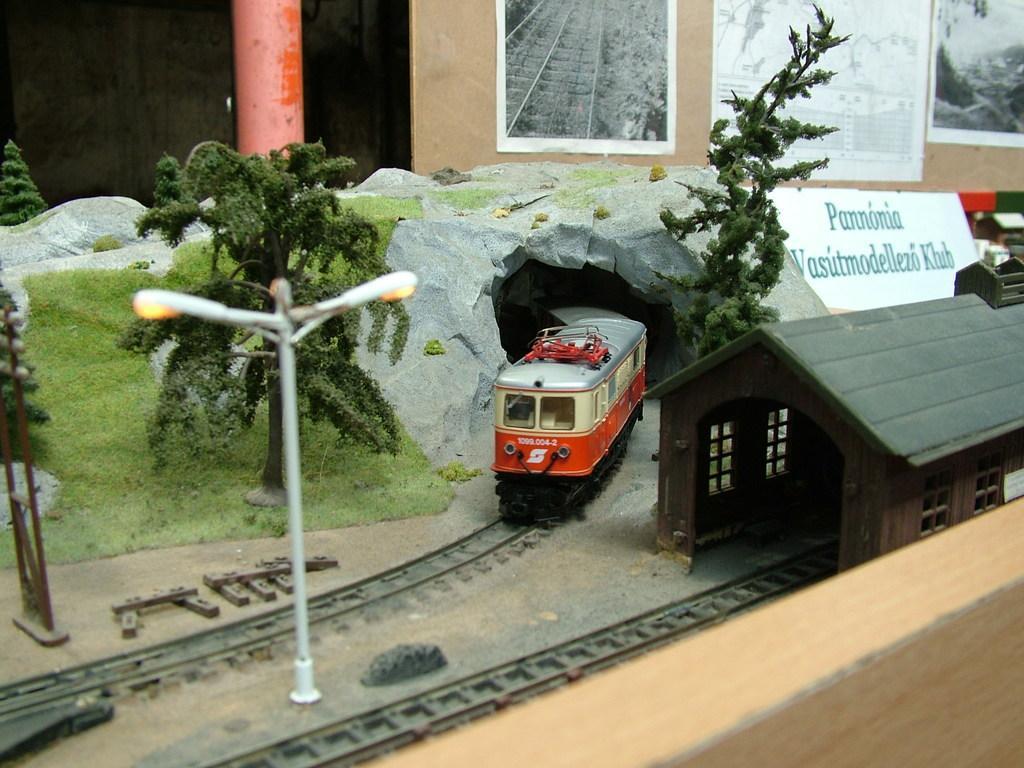Please provide a concise description of this image. In this image I can see a project of train coming from the cave beside that there is a hut and also there are trees and electrical poles, behind the project there is a notice board with some photos. 